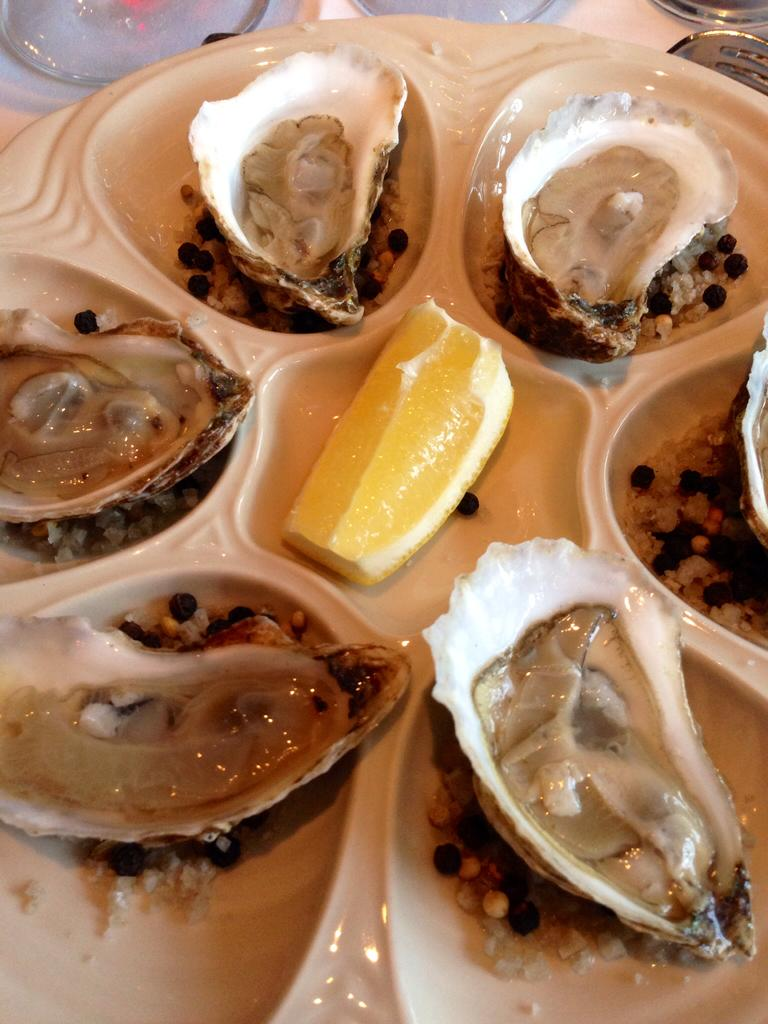What type of seafood is present in the image? There are six Chilean oysters in the image. How are the oysters arranged in the image? The oysters are on a plate. What accompaniment is present with the oysters? There is a lemon piece in the center of the plate. What advice does the governor give to the father in the image? There is no father or governor present in the image; it features six Chilean oysters on a plate with a lemon piece. 